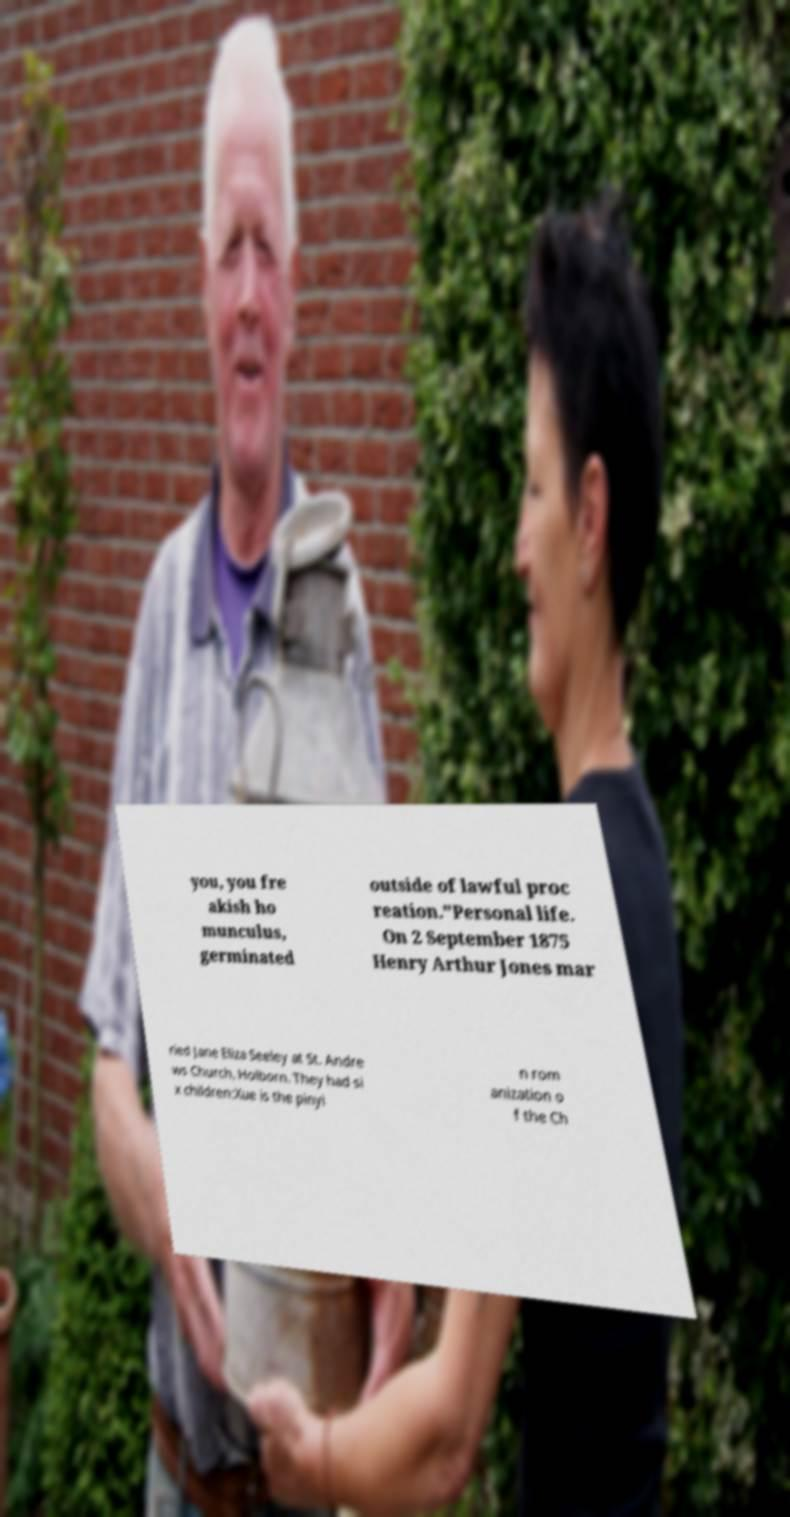I need the written content from this picture converted into text. Can you do that? you, you fre akish ho munculus, germinated outside of lawful proc reation."Personal life. On 2 September 1875 Henry Arthur Jones mar ried Jane Eliza Seeley at St. Andre ws Church, Holborn. They had si x children:Xue is the pinyi n rom anization o f the Ch 